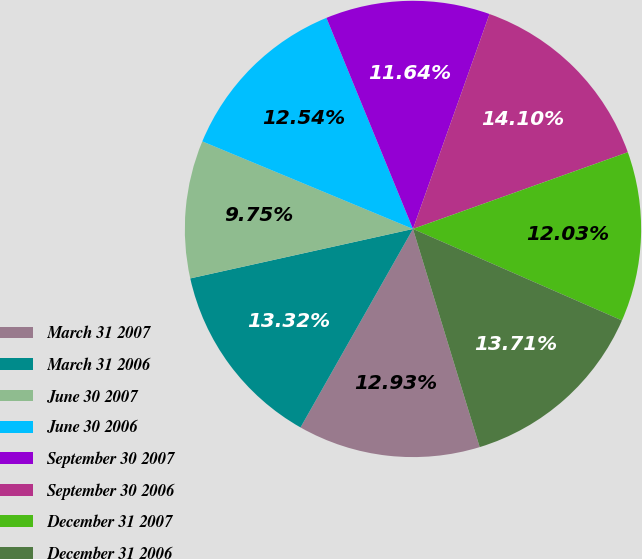Convert chart to OTSL. <chart><loc_0><loc_0><loc_500><loc_500><pie_chart><fcel>March 31 2007<fcel>March 31 2006<fcel>June 30 2007<fcel>June 30 2006<fcel>September 30 2007<fcel>September 30 2006<fcel>December 31 2007<fcel>December 31 2006<nl><fcel>12.93%<fcel>13.32%<fcel>9.75%<fcel>12.54%<fcel>11.64%<fcel>14.1%<fcel>12.03%<fcel>13.71%<nl></chart> 